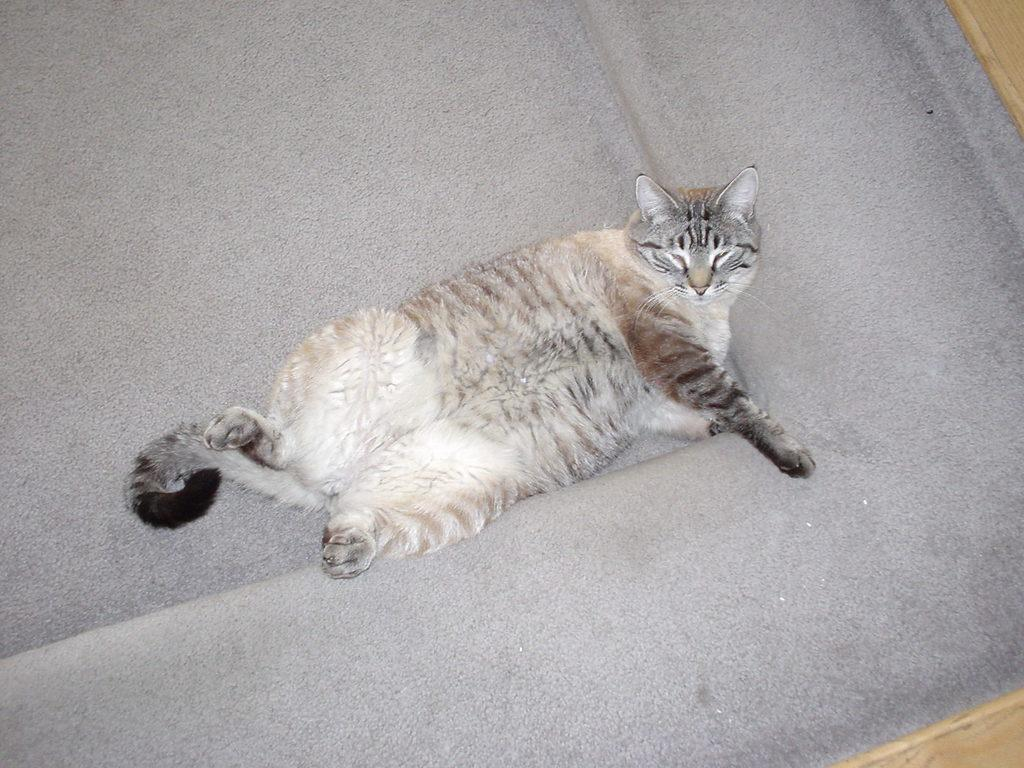What type of animal is in the image? There is a cat in the image. What surface is the cat on in the image? The cat is on a carpet. What type of fog can be seen in the image? There is no fog present in the image; it features a cat on a carpet. What type of musical instrument is being played in the image? There is no musical instrument being played in the image; it only features a cat on a carpet. 